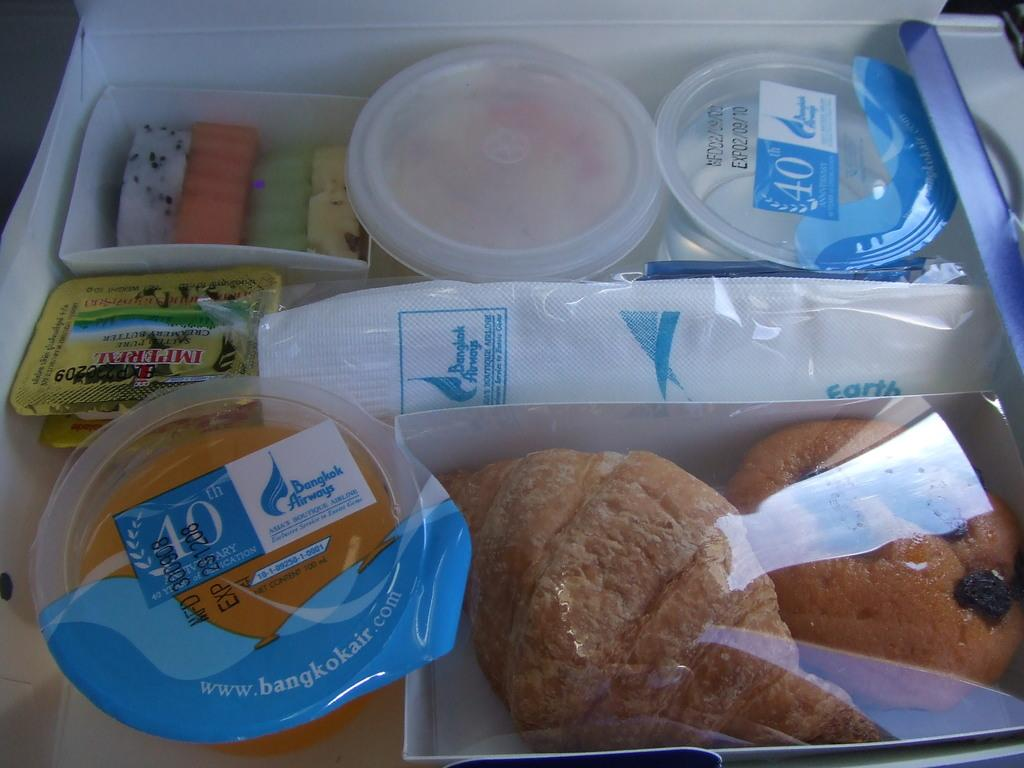What type of food is visible in the image? The image contains food, but the specific type cannot be determined from the provided facts. What is being served in the glasses in the image? There is juice in glasses in the image. Where are the tissue papers located in the image? The tissue papers are in a box in the image. On what surface are the items placed in the image? The items are placed on a surface in the image. What opinion is expressed in the notebook in the image? There is no notebook present in the image, so no opinion can be expressed. 